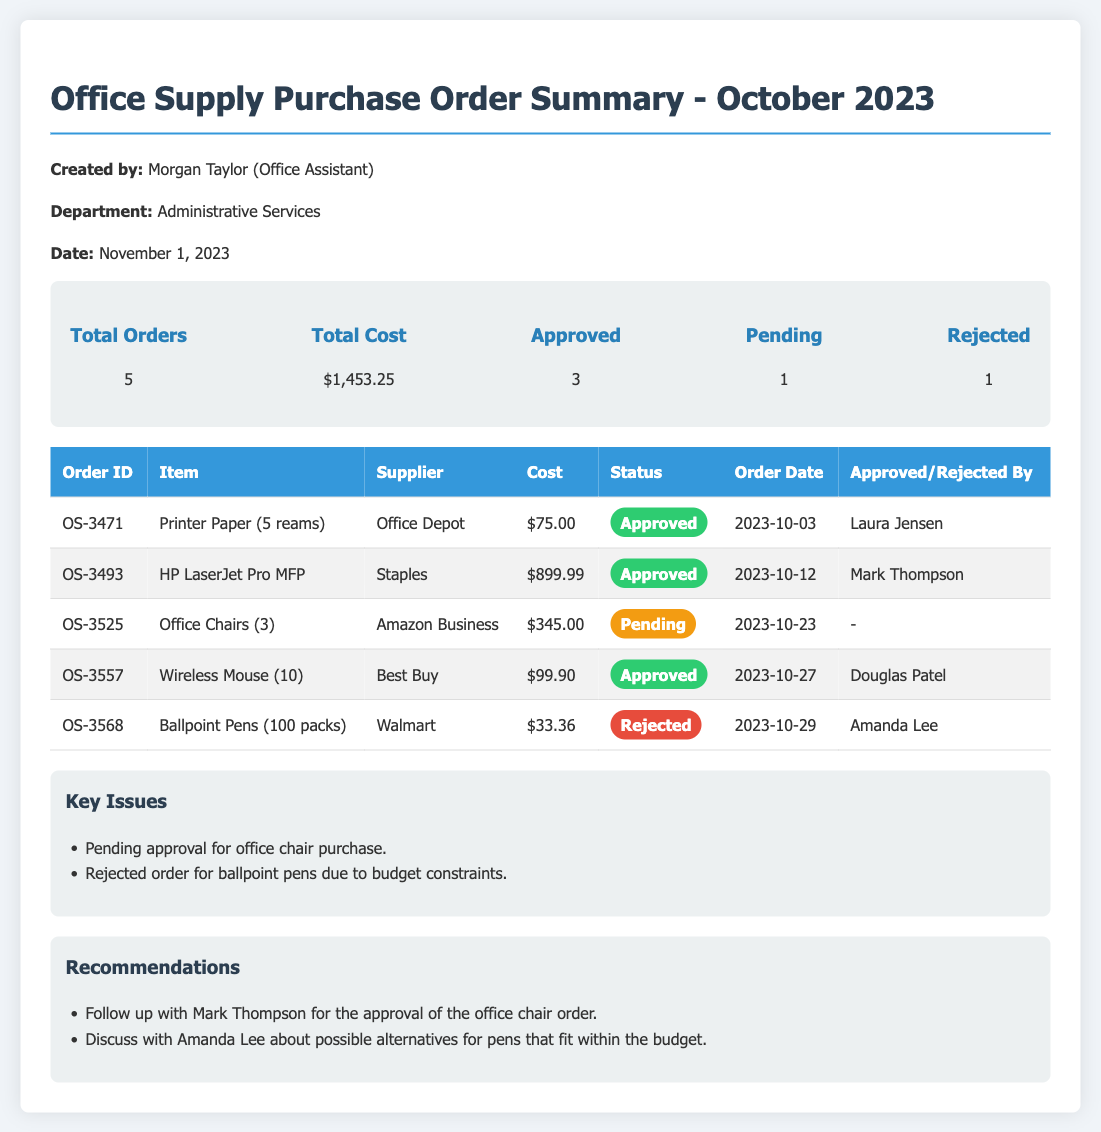What is the total cost of office supplies? The total cost is presented in the summary section of the document.
Answer: $1,453.25 How many orders were approved? The number of approved orders is listed in the summary section.
Answer: 3 What was the order date for the HP LaserJet Pro MFP? The order date for this specific item is found in the detailed table.
Answer: 2023-10-12 What is the status of the order for office chairs? The status is provided in the table under the status column for that specific order.
Answer: Pending Who approved the order for wireless mice? The person who approved this order is listed in the detailed table.
Answer: Douglas Patel What issue caused the rejection of the ballpoint pens order? The key issues are summarized in a dedicated section of the document.
Answer: Budget constraints What recommendation was made regarding the office chair order? The recommended action for this order is stated in the recommendations section.
Answer: Follow up with Mark Thompson What is the total number of orders? The total number of orders is recorded in the summary section.
Answer: 5 